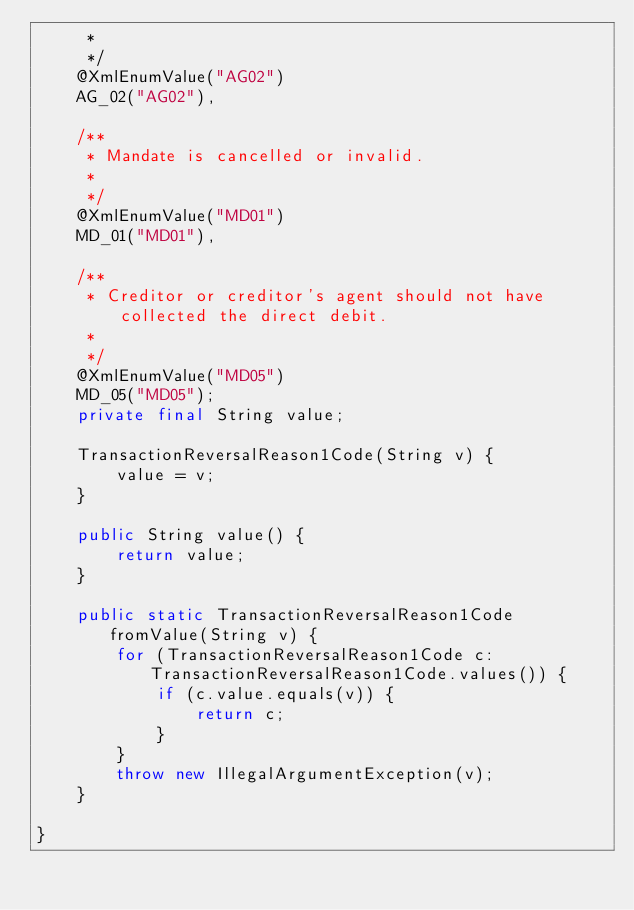<code> <loc_0><loc_0><loc_500><loc_500><_Java_>     * 
     */
    @XmlEnumValue("AG02")
    AG_02("AG02"),

    /**
     * Mandate is cancelled or invalid.
     * 
     */
    @XmlEnumValue("MD01")
    MD_01("MD01"),

    /**
     * Creditor or creditor's agent should not have collected the direct debit.
     * 
     */
    @XmlEnumValue("MD05")
    MD_05("MD05");
    private final String value;

    TransactionReversalReason1Code(String v) {
        value = v;
    }

    public String value() {
        return value;
    }

    public static TransactionReversalReason1Code fromValue(String v) {
        for (TransactionReversalReason1Code c: TransactionReversalReason1Code.values()) {
            if (c.value.equals(v)) {
                return c;
            }
        }
        throw new IllegalArgumentException(v);
    }

}
</code> 